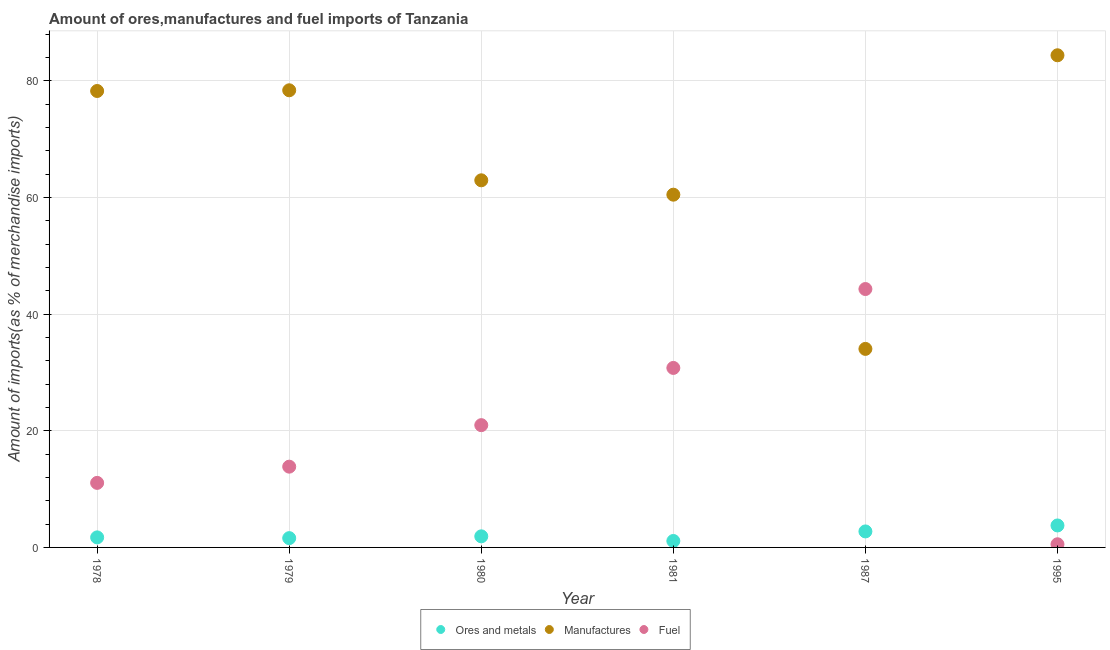How many different coloured dotlines are there?
Ensure brevity in your answer.  3. Is the number of dotlines equal to the number of legend labels?
Your answer should be very brief. Yes. What is the percentage of fuel imports in 1978?
Your response must be concise. 11.07. Across all years, what is the maximum percentage of manufactures imports?
Give a very brief answer. 84.4. Across all years, what is the minimum percentage of manufactures imports?
Provide a short and direct response. 34.05. What is the total percentage of ores and metals imports in the graph?
Provide a succinct answer. 12.84. What is the difference between the percentage of ores and metals imports in 1979 and that in 1980?
Make the answer very short. -0.31. What is the difference between the percentage of manufactures imports in 1979 and the percentage of ores and metals imports in 1980?
Offer a very short reply. 76.5. What is the average percentage of fuel imports per year?
Offer a very short reply. 20.25. In the year 1995, what is the difference between the percentage of manufactures imports and percentage of ores and metals imports?
Give a very brief answer. 80.63. What is the ratio of the percentage of ores and metals imports in 1978 to that in 1995?
Provide a short and direct response. 0.46. Is the percentage of manufactures imports in 1978 less than that in 1979?
Make the answer very short. Yes. What is the difference between the highest and the second highest percentage of fuel imports?
Offer a very short reply. 13.53. What is the difference between the highest and the lowest percentage of fuel imports?
Give a very brief answer. 43.77. Does the percentage of manufactures imports monotonically increase over the years?
Offer a terse response. No. Is the percentage of ores and metals imports strictly less than the percentage of manufactures imports over the years?
Provide a short and direct response. Yes. How many years are there in the graph?
Offer a very short reply. 6. What is the difference between two consecutive major ticks on the Y-axis?
Your response must be concise. 20. Are the values on the major ticks of Y-axis written in scientific E-notation?
Give a very brief answer. No. Does the graph contain any zero values?
Provide a succinct answer. No. Where does the legend appear in the graph?
Offer a very short reply. Bottom center. What is the title of the graph?
Provide a succinct answer. Amount of ores,manufactures and fuel imports of Tanzania. What is the label or title of the Y-axis?
Offer a very short reply. Amount of imports(as % of merchandise imports). What is the Amount of imports(as % of merchandise imports) in Ores and metals in 1978?
Your answer should be very brief. 1.72. What is the Amount of imports(as % of merchandise imports) of Manufactures in 1978?
Your answer should be very brief. 78.28. What is the Amount of imports(as % of merchandise imports) in Fuel in 1978?
Your answer should be very brief. 11.07. What is the Amount of imports(as % of merchandise imports) of Ores and metals in 1979?
Give a very brief answer. 1.59. What is the Amount of imports(as % of merchandise imports) in Manufactures in 1979?
Provide a succinct answer. 78.4. What is the Amount of imports(as % of merchandise imports) in Fuel in 1979?
Make the answer very short. 13.85. What is the Amount of imports(as % of merchandise imports) in Ores and metals in 1980?
Provide a short and direct response. 1.9. What is the Amount of imports(as % of merchandise imports) in Manufactures in 1980?
Make the answer very short. 62.96. What is the Amount of imports(as % of merchandise imports) in Fuel in 1980?
Provide a short and direct response. 20.97. What is the Amount of imports(as % of merchandise imports) in Ores and metals in 1981?
Ensure brevity in your answer.  1.11. What is the Amount of imports(as % of merchandise imports) in Manufactures in 1981?
Your answer should be very brief. 60.49. What is the Amount of imports(as % of merchandise imports) of Fuel in 1981?
Offer a very short reply. 30.78. What is the Amount of imports(as % of merchandise imports) of Ores and metals in 1987?
Provide a succinct answer. 2.74. What is the Amount of imports(as % of merchandise imports) in Manufactures in 1987?
Your answer should be compact. 34.05. What is the Amount of imports(as % of merchandise imports) of Fuel in 1987?
Keep it short and to the point. 44.31. What is the Amount of imports(as % of merchandise imports) in Ores and metals in 1995?
Your response must be concise. 3.77. What is the Amount of imports(as % of merchandise imports) in Manufactures in 1995?
Your answer should be very brief. 84.4. What is the Amount of imports(as % of merchandise imports) in Fuel in 1995?
Your answer should be compact. 0.54. Across all years, what is the maximum Amount of imports(as % of merchandise imports) in Ores and metals?
Ensure brevity in your answer.  3.77. Across all years, what is the maximum Amount of imports(as % of merchandise imports) in Manufactures?
Offer a very short reply. 84.4. Across all years, what is the maximum Amount of imports(as % of merchandise imports) in Fuel?
Your answer should be very brief. 44.31. Across all years, what is the minimum Amount of imports(as % of merchandise imports) in Ores and metals?
Offer a terse response. 1.11. Across all years, what is the minimum Amount of imports(as % of merchandise imports) in Manufactures?
Your response must be concise. 34.05. Across all years, what is the minimum Amount of imports(as % of merchandise imports) in Fuel?
Offer a very short reply. 0.54. What is the total Amount of imports(as % of merchandise imports) in Ores and metals in the graph?
Make the answer very short. 12.84. What is the total Amount of imports(as % of merchandise imports) of Manufactures in the graph?
Your answer should be compact. 398.58. What is the total Amount of imports(as % of merchandise imports) of Fuel in the graph?
Make the answer very short. 121.52. What is the difference between the Amount of imports(as % of merchandise imports) in Ores and metals in 1978 and that in 1979?
Provide a succinct answer. 0.13. What is the difference between the Amount of imports(as % of merchandise imports) of Manufactures in 1978 and that in 1979?
Your answer should be very brief. -0.12. What is the difference between the Amount of imports(as % of merchandise imports) in Fuel in 1978 and that in 1979?
Provide a succinct answer. -2.78. What is the difference between the Amount of imports(as % of merchandise imports) in Ores and metals in 1978 and that in 1980?
Offer a terse response. -0.18. What is the difference between the Amount of imports(as % of merchandise imports) in Manufactures in 1978 and that in 1980?
Your response must be concise. 15.32. What is the difference between the Amount of imports(as % of merchandise imports) of Ores and metals in 1978 and that in 1981?
Offer a very short reply. 0.62. What is the difference between the Amount of imports(as % of merchandise imports) in Manufactures in 1978 and that in 1981?
Ensure brevity in your answer.  17.78. What is the difference between the Amount of imports(as % of merchandise imports) of Fuel in 1978 and that in 1981?
Make the answer very short. -19.71. What is the difference between the Amount of imports(as % of merchandise imports) of Ores and metals in 1978 and that in 1987?
Make the answer very short. -1.02. What is the difference between the Amount of imports(as % of merchandise imports) in Manufactures in 1978 and that in 1987?
Provide a succinct answer. 44.23. What is the difference between the Amount of imports(as % of merchandise imports) in Fuel in 1978 and that in 1987?
Offer a very short reply. -33.24. What is the difference between the Amount of imports(as % of merchandise imports) of Ores and metals in 1978 and that in 1995?
Keep it short and to the point. -2.05. What is the difference between the Amount of imports(as % of merchandise imports) in Manufactures in 1978 and that in 1995?
Make the answer very short. -6.13. What is the difference between the Amount of imports(as % of merchandise imports) of Fuel in 1978 and that in 1995?
Your response must be concise. 10.53. What is the difference between the Amount of imports(as % of merchandise imports) in Ores and metals in 1979 and that in 1980?
Your answer should be compact. -0.31. What is the difference between the Amount of imports(as % of merchandise imports) of Manufactures in 1979 and that in 1980?
Provide a short and direct response. 15.44. What is the difference between the Amount of imports(as % of merchandise imports) in Fuel in 1979 and that in 1980?
Your answer should be very brief. -7.12. What is the difference between the Amount of imports(as % of merchandise imports) of Ores and metals in 1979 and that in 1981?
Your answer should be very brief. 0.49. What is the difference between the Amount of imports(as % of merchandise imports) in Manufactures in 1979 and that in 1981?
Your answer should be compact. 17.9. What is the difference between the Amount of imports(as % of merchandise imports) of Fuel in 1979 and that in 1981?
Provide a short and direct response. -16.93. What is the difference between the Amount of imports(as % of merchandise imports) of Ores and metals in 1979 and that in 1987?
Your answer should be compact. -1.15. What is the difference between the Amount of imports(as % of merchandise imports) of Manufactures in 1979 and that in 1987?
Offer a terse response. 44.35. What is the difference between the Amount of imports(as % of merchandise imports) in Fuel in 1979 and that in 1987?
Give a very brief answer. -30.46. What is the difference between the Amount of imports(as % of merchandise imports) in Ores and metals in 1979 and that in 1995?
Provide a short and direct response. -2.17. What is the difference between the Amount of imports(as % of merchandise imports) in Manufactures in 1979 and that in 1995?
Make the answer very short. -6. What is the difference between the Amount of imports(as % of merchandise imports) in Fuel in 1979 and that in 1995?
Give a very brief answer. 13.31. What is the difference between the Amount of imports(as % of merchandise imports) in Ores and metals in 1980 and that in 1981?
Give a very brief answer. 0.8. What is the difference between the Amount of imports(as % of merchandise imports) of Manufactures in 1980 and that in 1981?
Your answer should be compact. 2.47. What is the difference between the Amount of imports(as % of merchandise imports) in Fuel in 1980 and that in 1981?
Offer a terse response. -9.81. What is the difference between the Amount of imports(as % of merchandise imports) of Ores and metals in 1980 and that in 1987?
Offer a very short reply. -0.84. What is the difference between the Amount of imports(as % of merchandise imports) in Manufactures in 1980 and that in 1987?
Provide a short and direct response. 28.91. What is the difference between the Amount of imports(as % of merchandise imports) in Fuel in 1980 and that in 1987?
Provide a succinct answer. -23.34. What is the difference between the Amount of imports(as % of merchandise imports) of Ores and metals in 1980 and that in 1995?
Offer a terse response. -1.87. What is the difference between the Amount of imports(as % of merchandise imports) in Manufactures in 1980 and that in 1995?
Your answer should be very brief. -21.44. What is the difference between the Amount of imports(as % of merchandise imports) of Fuel in 1980 and that in 1995?
Provide a short and direct response. 20.43. What is the difference between the Amount of imports(as % of merchandise imports) in Ores and metals in 1981 and that in 1987?
Keep it short and to the point. -1.64. What is the difference between the Amount of imports(as % of merchandise imports) of Manufactures in 1981 and that in 1987?
Ensure brevity in your answer.  26.45. What is the difference between the Amount of imports(as % of merchandise imports) of Fuel in 1981 and that in 1987?
Offer a terse response. -13.53. What is the difference between the Amount of imports(as % of merchandise imports) in Ores and metals in 1981 and that in 1995?
Provide a succinct answer. -2.66. What is the difference between the Amount of imports(as % of merchandise imports) of Manufactures in 1981 and that in 1995?
Make the answer very short. -23.91. What is the difference between the Amount of imports(as % of merchandise imports) of Fuel in 1981 and that in 1995?
Offer a terse response. 30.24. What is the difference between the Amount of imports(as % of merchandise imports) in Ores and metals in 1987 and that in 1995?
Your answer should be compact. -1.02. What is the difference between the Amount of imports(as % of merchandise imports) in Manufactures in 1987 and that in 1995?
Offer a terse response. -50.35. What is the difference between the Amount of imports(as % of merchandise imports) of Fuel in 1987 and that in 1995?
Ensure brevity in your answer.  43.77. What is the difference between the Amount of imports(as % of merchandise imports) in Ores and metals in 1978 and the Amount of imports(as % of merchandise imports) in Manufactures in 1979?
Give a very brief answer. -76.68. What is the difference between the Amount of imports(as % of merchandise imports) in Ores and metals in 1978 and the Amount of imports(as % of merchandise imports) in Fuel in 1979?
Your response must be concise. -12.13. What is the difference between the Amount of imports(as % of merchandise imports) of Manufactures in 1978 and the Amount of imports(as % of merchandise imports) of Fuel in 1979?
Keep it short and to the point. 64.43. What is the difference between the Amount of imports(as % of merchandise imports) in Ores and metals in 1978 and the Amount of imports(as % of merchandise imports) in Manufactures in 1980?
Make the answer very short. -61.24. What is the difference between the Amount of imports(as % of merchandise imports) of Ores and metals in 1978 and the Amount of imports(as % of merchandise imports) of Fuel in 1980?
Offer a very short reply. -19.25. What is the difference between the Amount of imports(as % of merchandise imports) of Manufactures in 1978 and the Amount of imports(as % of merchandise imports) of Fuel in 1980?
Your answer should be compact. 57.31. What is the difference between the Amount of imports(as % of merchandise imports) of Ores and metals in 1978 and the Amount of imports(as % of merchandise imports) of Manufactures in 1981?
Give a very brief answer. -58.77. What is the difference between the Amount of imports(as % of merchandise imports) in Ores and metals in 1978 and the Amount of imports(as % of merchandise imports) in Fuel in 1981?
Ensure brevity in your answer.  -29.06. What is the difference between the Amount of imports(as % of merchandise imports) of Manufactures in 1978 and the Amount of imports(as % of merchandise imports) of Fuel in 1981?
Give a very brief answer. 47.49. What is the difference between the Amount of imports(as % of merchandise imports) of Ores and metals in 1978 and the Amount of imports(as % of merchandise imports) of Manufactures in 1987?
Provide a succinct answer. -32.33. What is the difference between the Amount of imports(as % of merchandise imports) in Ores and metals in 1978 and the Amount of imports(as % of merchandise imports) in Fuel in 1987?
Your answer should be very brief. -42.59. What is the difference between the Amount of imports(as % of merchandise imports) of Manufactures in 1978 and the Amount of imports(as % of merchandise imports) of Fuel in 1987?
Give a very brief answer. 33.96. What is the difference between the Amount of imports(as % of merchandise imports) in Ores and metals in 1978 and the Amount of imports(as % of merchandise imports) in Manufactures in 1995?
Ensure brevity in your answer.  -82.68. What is the difference between the Amount of imports(as % of merchandise imports) of Ores and metals in 1978 and the Amount of imports(as % of merchandise imports) of Fuel in 1995?
Ensure brevity in your answer.  1.18. What is the difference between the Amount of imports(as % of merchandise imports) of Manufactures in 1978 and the Amount of imports(as % of merchandise imports) of Fuel in 1995?
Give a very brief answer. 77.74. What is the difference between the Amount of imports(as % of merchandise imports) of Ores and metals in 1979 and the Amount of imports(as % of merchandise imports) of Manufactures in 1980?
Your answer should be compact. -61.37. What is the difference between the Amount of imports(as % of merchandise imports) in Ores and metals in 1979 and the Amount of imports(as % of merchandise imports) in Fuel in 1980?
Your answer should be compact. -19.37. What is the difference between the Amount of imports(as % of merchandise imports) in Manufactures in 1979 and the Amount of imports(as % of merchandise imports) in Fuel in 1980?
Your answer should be very brief. 57.43. What is the difference between the Amount of imports(as % of merchandise imports) of Ores and metals in 1979 and the Amount of imports(as % of merchandise imports) of Manufactures in 1981?
Make the answer very short. -58.9. What is the difference between the Amount of imports(as % of merchandise imports) of Ores and metals in 1979 and the Amount of imports(as % of merchandise imports) of Fuel in 1981?
Give a very brief answer. -29.19. What is the difference between the Amount of imports(as % of merchandise imports) in Manufactures in 1979 and the Amount of imports(as % of merchandise imports) in Fuel in 1981?
Provide a short and direct response. 47.62. What is the difference between the Amount of imports(as % of merchandise imports) of Ores and metals in 1979 and the Amount of imports(as % of merchandise imports) of Manufactures in 1987?
Provide a short and direct response. -32.45. What is the difference between the Amount of imports(as % of merchandise imports) in Ores and metals in 1979 and the Amount of imports(as % of merchandise imports) in Fuel in 1987?
Make the answer very short. -42.72. What is the difference between the Amount of imports(as % of merchandise imports) of Manufactures in 1979 and the Amount of imports(as % of merchandise imports) of Fuel in 1987?
Offer a terse response. 34.08. What is the difference between the Amount of imports(as % of merchandise imports) in Ores and metals in 1979 and the Amount of imports(as % of merchandise imports) in Manufactures in 1995?
Make the answer very short. -82.81. What is the difference between the Amount of imports(as % of merchandise imports) of Ores and metals in 1979 and the Amount of imports(as % of merchandise imports) of Fuel in 1995?
Your response must be concise. 1.05. What is the difference between the Amount of imports(as % of merchandise imports) in Manufactures in 1979 and the Amount of imports(as % of merchandise imports) in Fuel in 1995?
Give a very brief answer. 77.86. What is the difference between the Amount of imports(as % of merchandise imports) in Ores and metals in 1980 and the Amount of imports(as % of merchandise imports) in Manufactures in 1981?
Your answer should be very brief. -58.59. What is the difference between the Amount of imports(as % of merchandise imports) of Ores and metals in 1980 and the Amount of imports(as % of merchandise imports) of Fuel in 1981?
Offer a very short reply. -28.88. What is the difference between the Amount of imports(as % of merchandise imports) in Manufactures in 1980 and the Amount of imports(as % of merchandise imports) in Fuel in 1981?
Your answer should be compact. 32.18. What is the difference between the Amount of imports(as % of merchandise imports) of Ores and metals in 1980 and the Amount of imports(as % of merchandise imports) of Manufactures in 1987?
Offer a terse response. -32.15. What is the difference between the Amount of imports(as % of merchandise imports) in Ores and metals in 1980 and the Amount of imports(as % of merchandise imports) in Fuel in 1987?
Keep it short and to the point. -42.41. What is the difference between the Amount of imports(as % of merchandise imports) in Manufactures in 1980 and the Amount of imports(as % of merchandise imports) in Fuel in 1987?
Your response must be concise. 18.65. What is the difference between the Amount of imports(as % of merchandise imports) in Ores and metals in 1980 and the Amount of imports(as % of merchandise imports) in Manufactures in 1995?
Your response must be concise. -82.5. What is the difference between the Amount of imports(as % of merchandise imports) in Ores and metals in 1980 and the Amount of imports(as % of merchandise imports) in Fuel in 1995?
Provide a short and direct response. 1.36. What is the difference between the Amount of imports(as % of merchandise imports) in Manufactures in 1980 and the Amount of imports(as % of merchandise imports) in Fuel in 1995?
Offer a terse response. 62.42. What is the difference between the Amount of imports(as % of merchandise imports) in Ores and metals in 1981 and the Amount of imports(as % of merchandise imports) in Manufactures in 1987?
Give a very brief answer. -32.94. What is the difference between the Amount of imports(as % of merchandise imports) of Ores and metals in 1981 and the Amount of imports(as % of merchandise imports) of Fuel in 1987?
Make the answer very short. -43.21. What is the difference between the Amount of imports(as % of merchandise imports) in Manufactures in 1981 and the Amount of imports(as % of merchandise imports) in Fuel in 1987?
Your response must be concise. 16.18. What is the difference between the Amount of imports(as % of merchandise imports) of Ores and metals in 1981 and the Amount of imports(as % of merchandise imports) of Manufactures in 1995?
Ensure brevity in your answer.  -83.3. What is the difference between the Amount of imports(as % of merchandise imports) in Ores and metals in 1981 and the Amount of imports(as % of merchandise imports) in Fuel in 1995?
Your answer should be compact. 0.57. What is the difference between the Amount of imports(as % of merchandise imports) in Manufactures in 1981 and the Amount of imports(as % of merchandise imports) in Fuel in 1995?
Provide a short and direct response. 59.95. What is the difference between the Amount of imports(as % of merchandise imports) of Ores and metals in 1987 and the Amount of imports(as % of merchandise imports) of Manufactures in 1995?
Offer a very short reply. -81.66. What is the difference between the Amount of imports(as % of merchandise imports) in Ores and metals in 1987 and the Amount of imports(as % of merchandise imports) in Fuel in 1995?
Give a very brief answer. 2.2. What is the difference between the Amount of imports(as % of merchandise imports) of Manufactures in 1987 and the Amount of imports(as % of merchandise imports) of Fuel in 1995?
Offer a terse response. 33.51. What is the average Amount of imports(as % of merchandise imports) in Ores and metals per year?
Give a very brief answer. 2.14. What is the average Amount of imports(as % of merchandise imports) of Manufactures per year?
Offer a terse response. 66.43. What is the average Amount of imports(as % of merchandise imports) of Fuel per year?
Keep it short and to the point. 20.25. In the year 1978, what is the difference between the Amount of imports(as % of merchandise imports) of Ores and metals and Amount of imports(as % of merchandise imports) of Manufactures?
Offer a terse response. -76.55. In the year 1978, what is the difference between the Amount of imports(as % of merchandise imports) in Ores and metals and Amount of imports(as % of merchandise imports) in Fuel?
Your response must be concise. -9.35. In the year 1978, what is the difference between the Amount of imports(as % of merchandise imports) in Manufactures and Amount of imports(as % of merchandise imports) in Fuel?
Keep it short and to the point. 67.21. In the year 1979, what is the difference between the Amount of imports(as % of merchandise imports) of Ores and metals and Amount of imports(as % of merchandise imports) of Manufactures?
Ensure brevity in your answer.  -76.8. In the year 1979, what is the difference between the Amount of imports(as % of merchandise imports) in Ores and metals and Amount of imports(as % of merchandise imports) in Fuel?
Give a very brief answer. -12.26. In the year 1979, what is the difference between the Amount of imports(as % of merchandise imports) of Manufactures and Amount of imports(as % of merchandise imports) of Fuel?
Provide a succinct answer. 64.55. In the year 1980, what is the difference between the Amount of imports(as % of merchandise imports) of Ores and metals and Amount of imports(as % of merchandise imports) of Manufactures?
Offer a very short reply. -61.06. In the year 1980, what is the difference between the Amount of imports(as % of merchandise imports) of Ores and metals and Amount of imports(as % of merchandise imports) of Fuel?
Offer a terse response. -19.07. In the year 1980, what is the difference between the Amount of imports(as % of merchandise imports) in Manufactures and Amount of imports(as % of merchandise imports) in Fuel?
Your answer should be very brief. 41.99. In the year 1981, what is the difference between the Amount of imports(as % of merchandise imports) of Ores and metals and Amount of imports(as % of merchandise imports) of Manufactures?
Make the answer very short. -59.39. In the year 1981, what is the difference between the Amount of imports(as % of merchandise imports) of Ores and metals and Amount of imports(as % of merchandise imports) of Fuel?
Provide a short and direct response. -29.68. In the year 1981, what is the difference between the Amount of imports(as % of merchandise imports) in Manufactures and Amount of imports(as % of merchandise imports) in Fuel?
Your answer should be very brief. 29.71. In the year 1987, what is the difference between the Amount of imports(as % of merchandise imports) in Ores and metals and Amount of imports(as % of merchandise imports) in Manufactures?
Ensure brevity in your answer.  -31.3. In the year 1987, what is the difference between the Amount of imports(as % of merchandise imports) of Ores and metals and Amount of imports(as % of merchandise imports) of Fuel?
Provide a short and direct response. -41.57. In the year 1987, what is the difference between the Amount of imports(as % of merchandise imports) of Manufactures and Amount of imports(as % of merchandise imports) of Fuel?
Your answer should be very brief. -10.27. In the year 1995, what is the difference between the Amount of imports(as % of merchandise imports) of Ores and metals and Amount of imports(as % of merchandise imports) of Manufactures?
Ensure brevity in your answer.  -80.63. In the year 1995, what is the difference between the Amount of imports(as % of merchandise imports) in Ores and metals and Amount of imports(as % of merchandise imports) in Fuel?
Give a very brief answer. 3.23. In the year 1995, what is the difference between the Amount of imports(as % of merchandise imports) of Manufactures and Amount of imports(as % of merchandise imports) of Fuel?
Your answer should be very brief. 83.86. What is the ratio of the Amount of imports(as % of merchandise imports) in Ores and metals in 1978 to that in 1979?
Offer a very short reply. 1.08. What is the ratio of the Amount of imports(as % of merchandise imports) in Fuel in 1978 to that in 1979?
Offer a very short reply. 0.8. What is the ratio of the Amount of imports(as % of merchandise imports) in Ores and metals in 1978 to that in 1980?
Your answer should be compact. 0.91. What is the ratio of the Amount of imports(as % of merchandise imports) in Manufactures in 1978 to that in 1980?
Offer a terse response. 1.24. What is the ratio of the Amount of imports(as % of merchandise imports) of Fuel in 1978 to that in 1980?
Your answer should be very brief. 0.53. What is the ratio of the Amount of imports(as % of merchandise imports) of Ores and metals in 1978 to that in 1981?
Your answer should be very brief. 1.56. What is the ratio of the Amount of imports(as % of merchandise imports) of Manufactures in 1978 to that in 1981?
Provide a succinct answer. 1.29. What is the ratio of the Amount of imports(as % of merchandise imports) in Fuel in 1978 to that in 1981?
Make the answer very short. 0.36. What is the ratio of the Amount of imports(as % of merchandise imports) in Ores and metals in 1978 to that in 1987?
Offer a very short reply. 0.63. What is the ratio of the Amount of imports(as % of merchandise imports) in Manufactures in 1978 to that in 1987?
Your response must be concise. 2.3. What is the ratio of the Amount of imports(as % of merchandise imports) in Fuel in 1978 to that in 1987?
Give a very brief answer. 0.25. What is the ratio of the Amount of imports(as % of merchandise imports) in Ores and metals in 1978 to that in 1995?
Offer a very short reply. 0.46. What is the ratio of the Amount of imports(as % of merchandise imports) in Manufactures in 1978 to that in 1995?
Ensure brevity in your answer.  0.93. What is the ratio of the Amount of imports(as % of merchandise imports) in Fuel in 1978 to that in 1995?
Provide a short and direct response. 20.47. What is the ratio of the Amount of imports(as % of merchandise imports) in Ores and metals in 1979 to that in 1980?
Make the answer very short. 0.84. What is the ratio of the Amount of imports(as % of merchandise imports) of Manufactures in 1979 to that in 1980?
Provide a short and direct response. 1.25. What is the ratio of the Amount of imports(as % of merchandise imports) in Fuel in 1979 to that in 1980?
Give a very brief answer. 0.66. What is the ratio of the Amount of imports(as % of merchandise imports) in Ores and metals in 1979 to that in 1981?
Your answer should be compact. 1.44. What is the ratio of the Amount of imports(as % of merchandise imports) of Manufactures in 1979 to that in 1981?
Your answer should be compact. 1.3. What is the ratio of the Amount of imports(as % of merchandise imports) in Fuel in 1979 to that in 1981?
Your answer should be compact. 0.45. What is the ratio of the Amount of imports(as % of merchandise imports) of Ores and metals in 1979 to that in 1987?
Provide a succinct answer. 0.58. What is the ratio of the Amount of imports(as % of merchandise imports) of Manufactures in 1979 to that in 1987?
Provide a short and direct response. 2.3. What is the ratio of the Amount of imports(as % of merchandise imports) of Fuel in 1979 to that in 1987?
Keep it short and to the point. 0.31. What is the ratio of the Amount of imports(as % of merchandise imports) of Ores and metals in 1979 to that in 1995?
Give a very brief answer. 0.42. What is the ratio of the Amount of imports(as % of merchandise imports) of Manufactures in 1979 to that in 1995?
Provide a succinct answer. 0.93. What is the ratio of the Amount of imports(as % of merchandise imports) in Fuel in 1979 to that in 1995?
Offer a terse response. 25.61. What is the ratio of the Amount of imports(as % of merchandise imports) in Ores and metals in 1980 to that in 1981?
Provide a succinct answer. 1.72. What is the ratio of the Amount of imports(as % of merchandise imports) of Manufactures in 1980 to that in 1981?
Provide a succinct answer. 1.04. What is the ratio of the Amount of imports(as % of merchandise imports) of Fuel in 1980 to that in 1981?
Offer a terse response. 0.68. What is the ratio of the Amount of imports(as % of merchandise imports) in Ores and metals in 1980 to that in 1987?
Provide a short and direct response. 0.69. What is the ratio of the Amount of imports(as % of merchandise imports) in Manufactures in 1980 to that in 1987?
Ensure brevity in your answer.  1.85. What is the ratio of the Amount of imports(as % of merchandise imports) of Fuel in 1980 to that in 1987?
Provide a short and direct response. 0.47. What is the ratio of the Amount of imports(as % of merchandise imports) in Ores and metals in 1980 to that in 1995?
Provide a succinct answer. 0.5. What is the ratio of the Amount of imports(as % of merchandise imports) of Manufactures in 1980 to that in 1995?
Make the answer very short. 0.75. What is the ratio of the Amount of imports(as % of merchandise imports) of Fuel in 1980 to that in 1995?
Provide a short and direct response. 38.78. What is the ratio of the Amount of imports(as % of merchandise imports) in Ores and metals in 1981 to that in 1987?
Your answer should be compact. 0.4. What is the ratio of the Amount of imports(as % of merchandise imports) in Manufactures in 1981 to that in 1987?
Provide a short and direct response. 1.78. What is the ratio of the Amount of imports(as % of merchandise imports) of Fuel in 1981 to that in 1987?
Keep it short and to the point. 0.69. What is the ratio of the Amount of imports(as % of merchandise imports) of Ores and metals in 1981 to that in 1995?
Provide a short and direct response. 0.29. What is the ratio of the Amount of imports(as % of merchandise imports) in Manufactures in 1981 to that in 1995?
Give a very brief answer. 0.72. What is the ratio of the Amount of imports(as % of merchandise imports) of Fuel in 1981 to that in 1995?
Your response must be concise. 56.93. What is the ratio of the Amount of imports(as % of merchandise imports) in Ores and metals in 1987 to that in 1995?
Your answer should be very brief. 0.73. What is the ratio of the Amount of imports(as % of merchandise imports) in Manufactures in 1987 to that in 1995?
Provide a succinct answer. 0.4. What is the ratio of the Amount of imports(as % of merchandise imports) of Fuel in 1987 to that in 1995?
Give a very brief answer. 81.95. What is the difference between the highest and the second highest Amount of imports(as % of merchandise imports) in Manufactures?
Your answer should be very brief. 6. What is the difference between the highest and the second highest Amount of imports(as % of merchandise imports) of Fuel?
Your answer should be compact. 13.53. What is the difference between the highest and the lowest Amount of imports(as % of merchandise imports) in Ores and metals?
Ensure brevity in your answer.  2.66. What is the difference between the highest and the lowest Amount of imports(as % of merchandise imports) of Manufactures?
Ensure brevity in your answer.  50.35. What is the difference between the highest and the lowest Amount of imports(as % of merchandise imports) in Fuel?
Offer a very short reply. 43.77. 